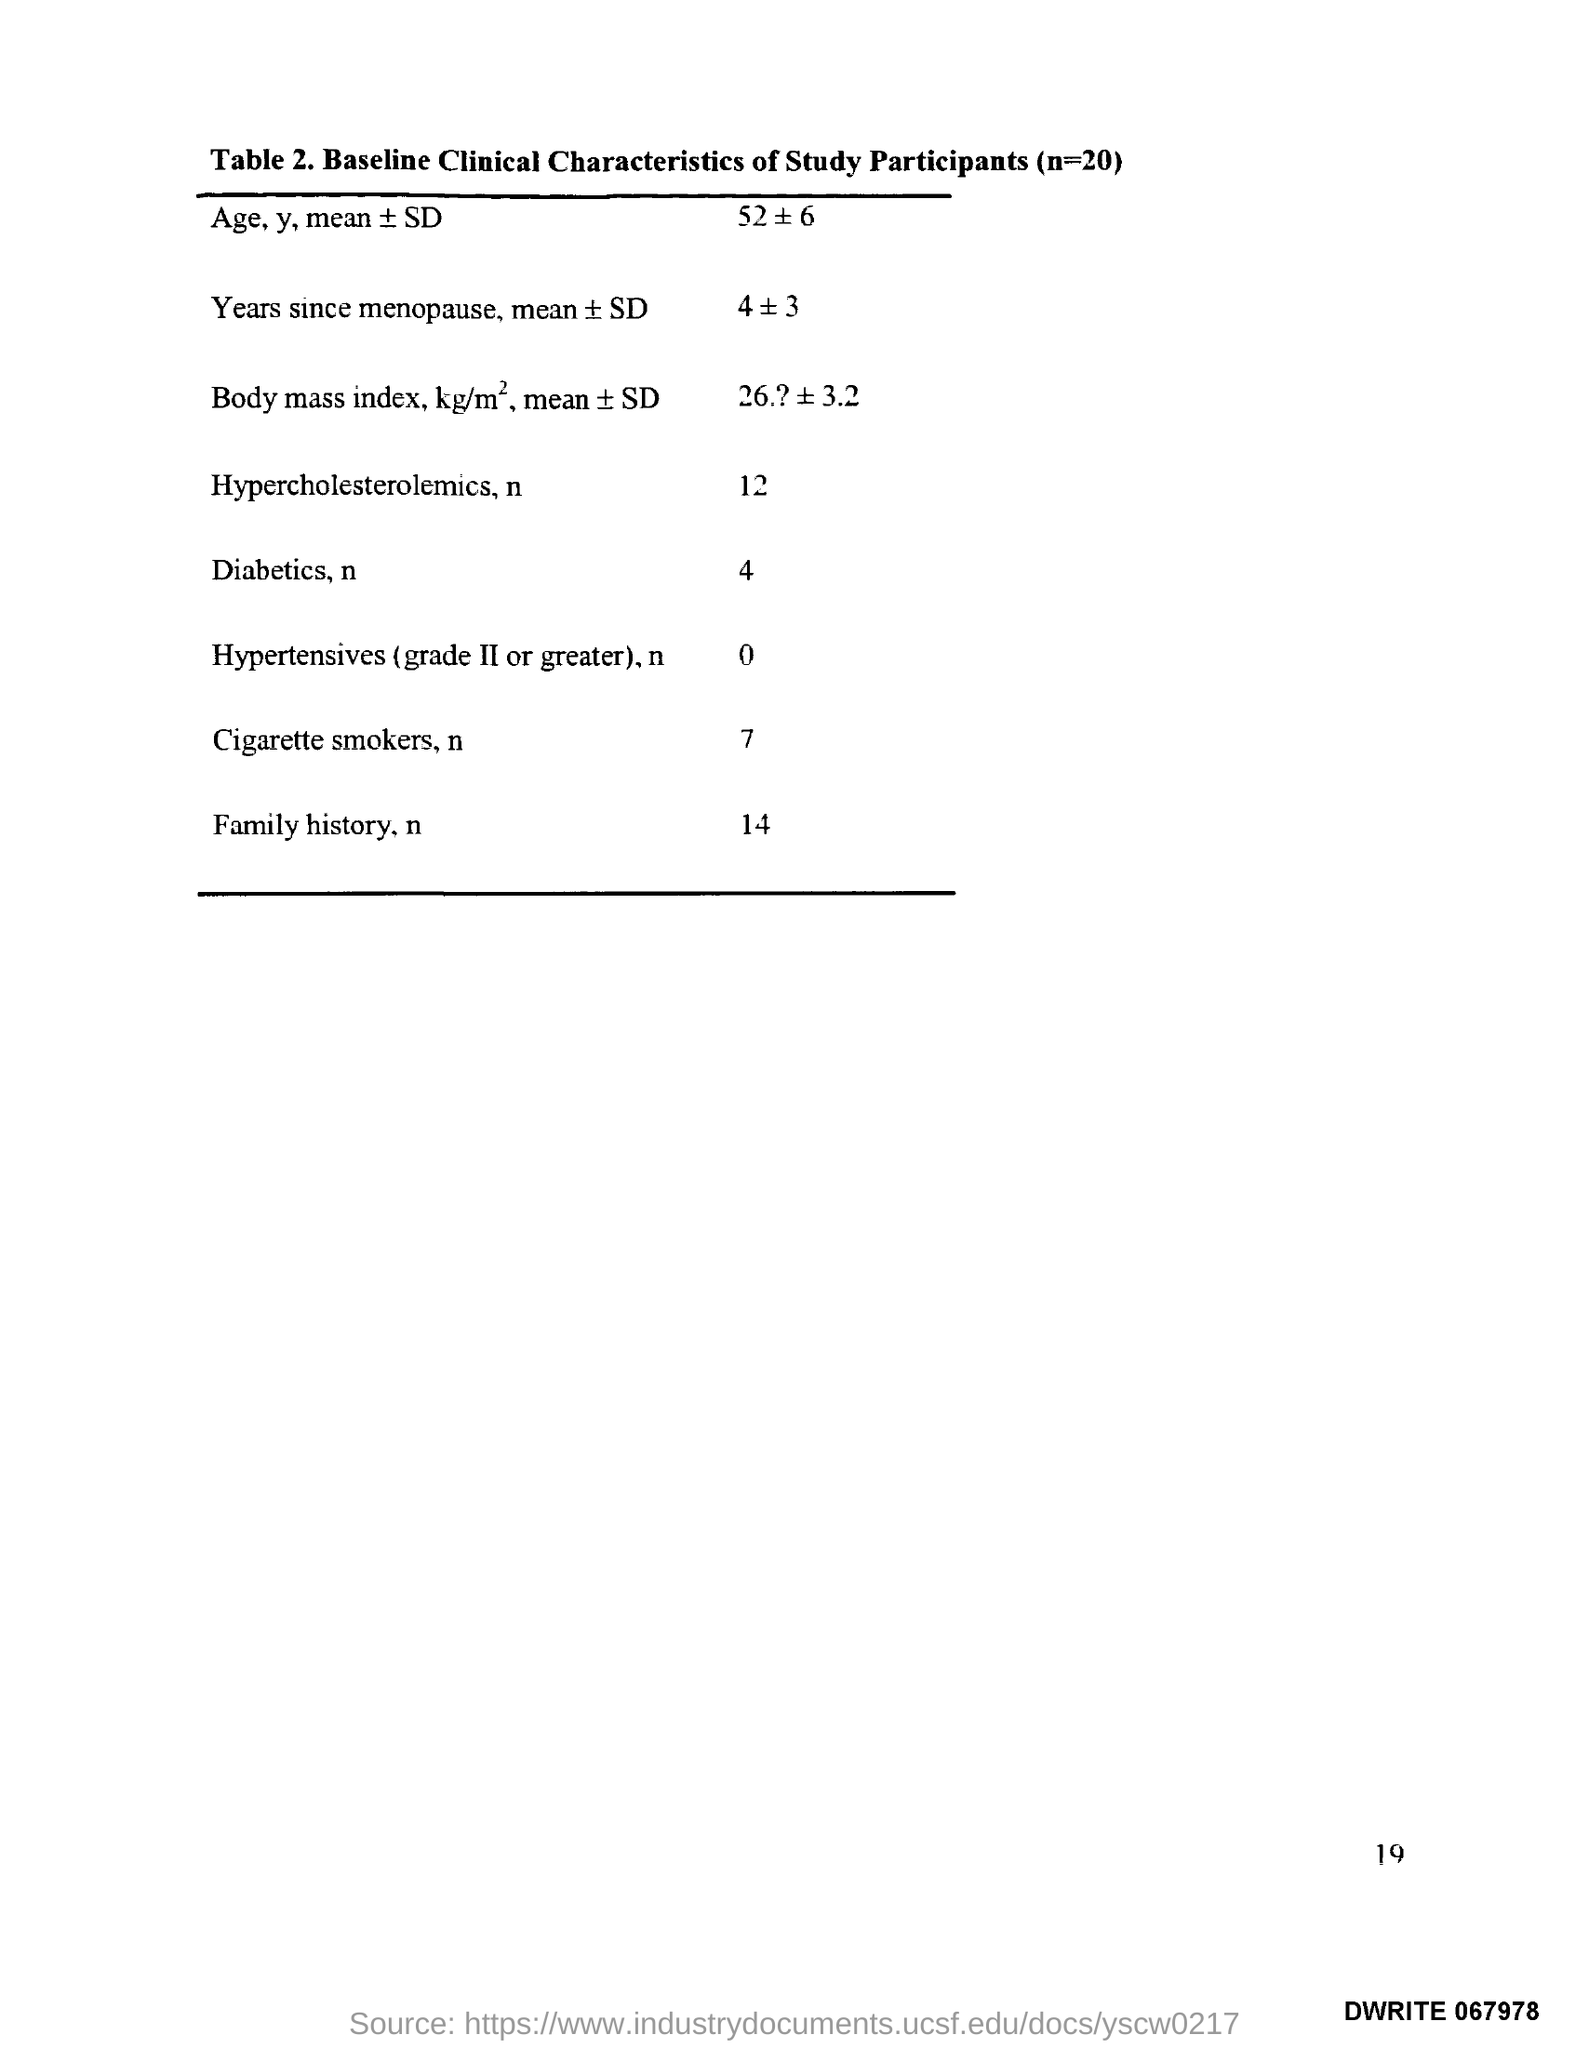What is the title of Table 2.?
Provide a succinct answer. Baseline Clinical Characteristics of Study Participants (n=20). 